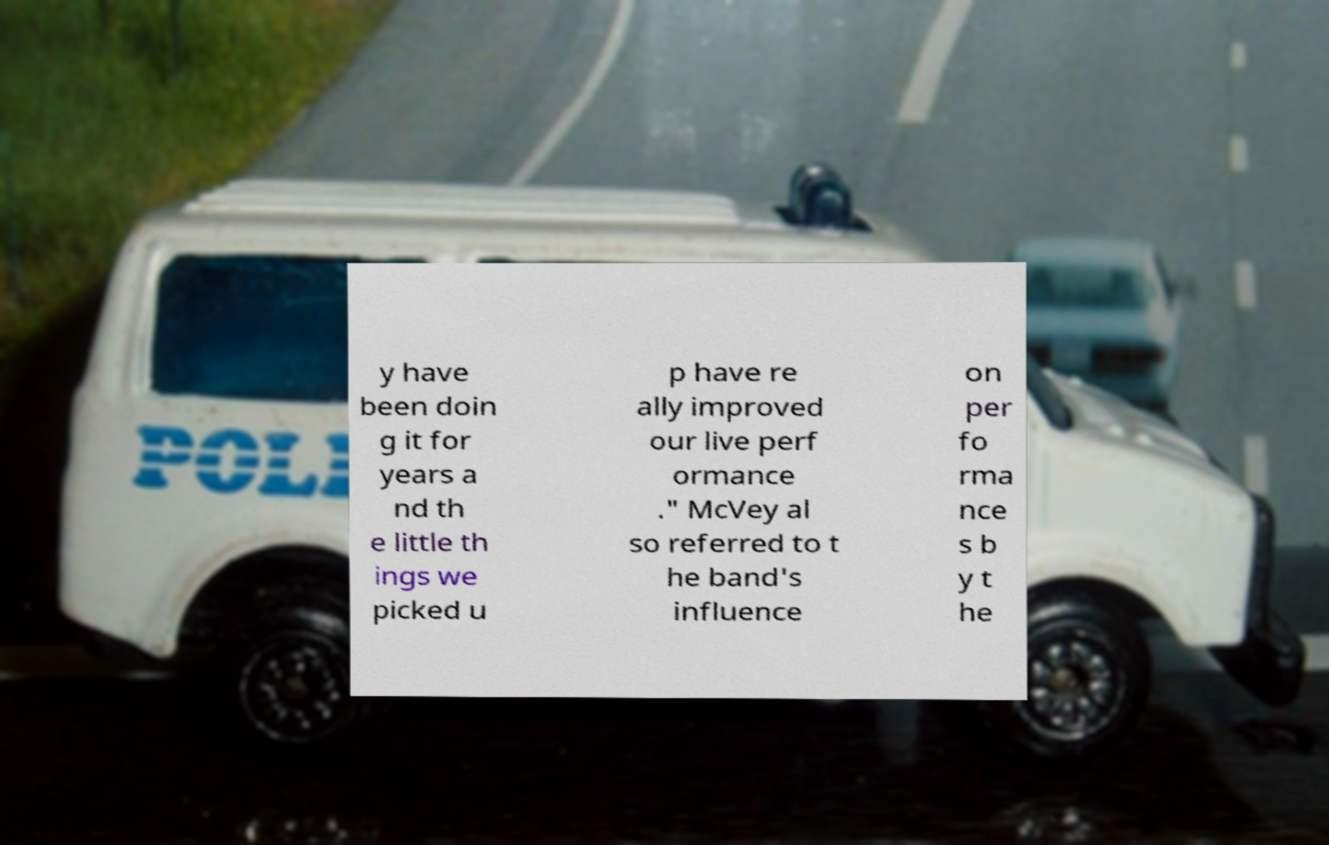Could you assist in decoding the text presented in this image and type it out clearly? y have been doin g it for years a nd th e little th ings we picked u p have re ally improved our live perf ormance ." McVey al so referred to t he band's influence on per fo rma nce s b y t he 